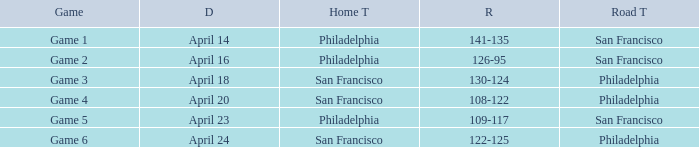Which game featured philadelphia as its host team and took place on april 23? Game 5. 